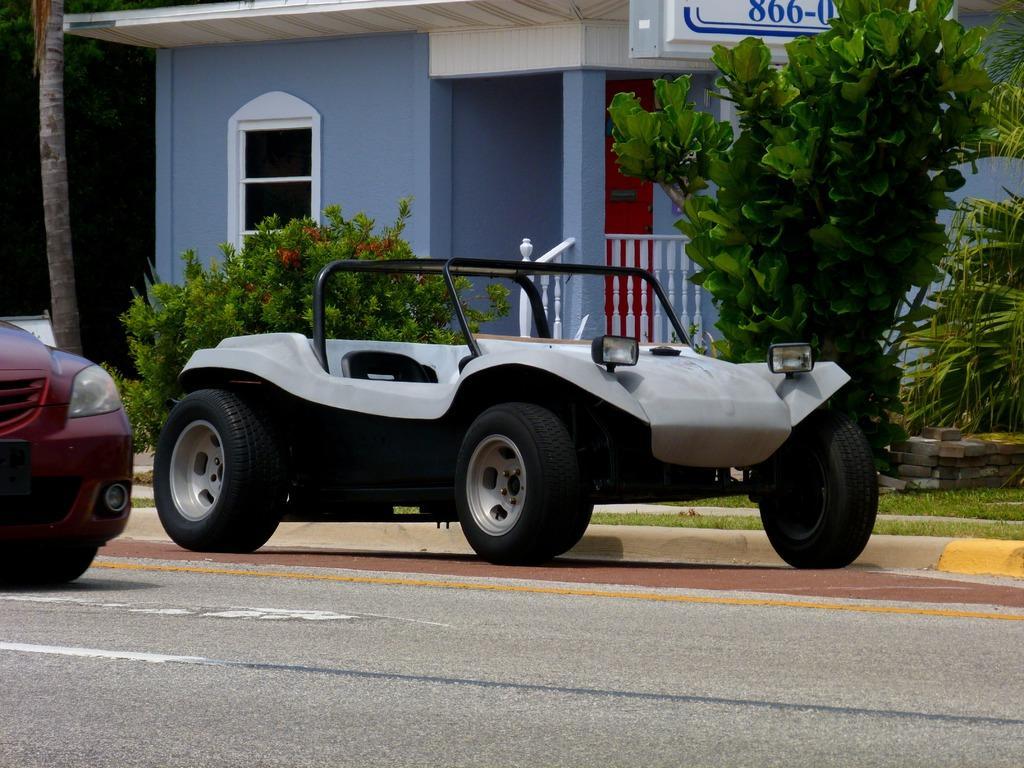How would you summarize this image in a sentence or two? In this image there are two vehicles. There are trees and plants. There are grass and stones. There is a house. There is a road. 